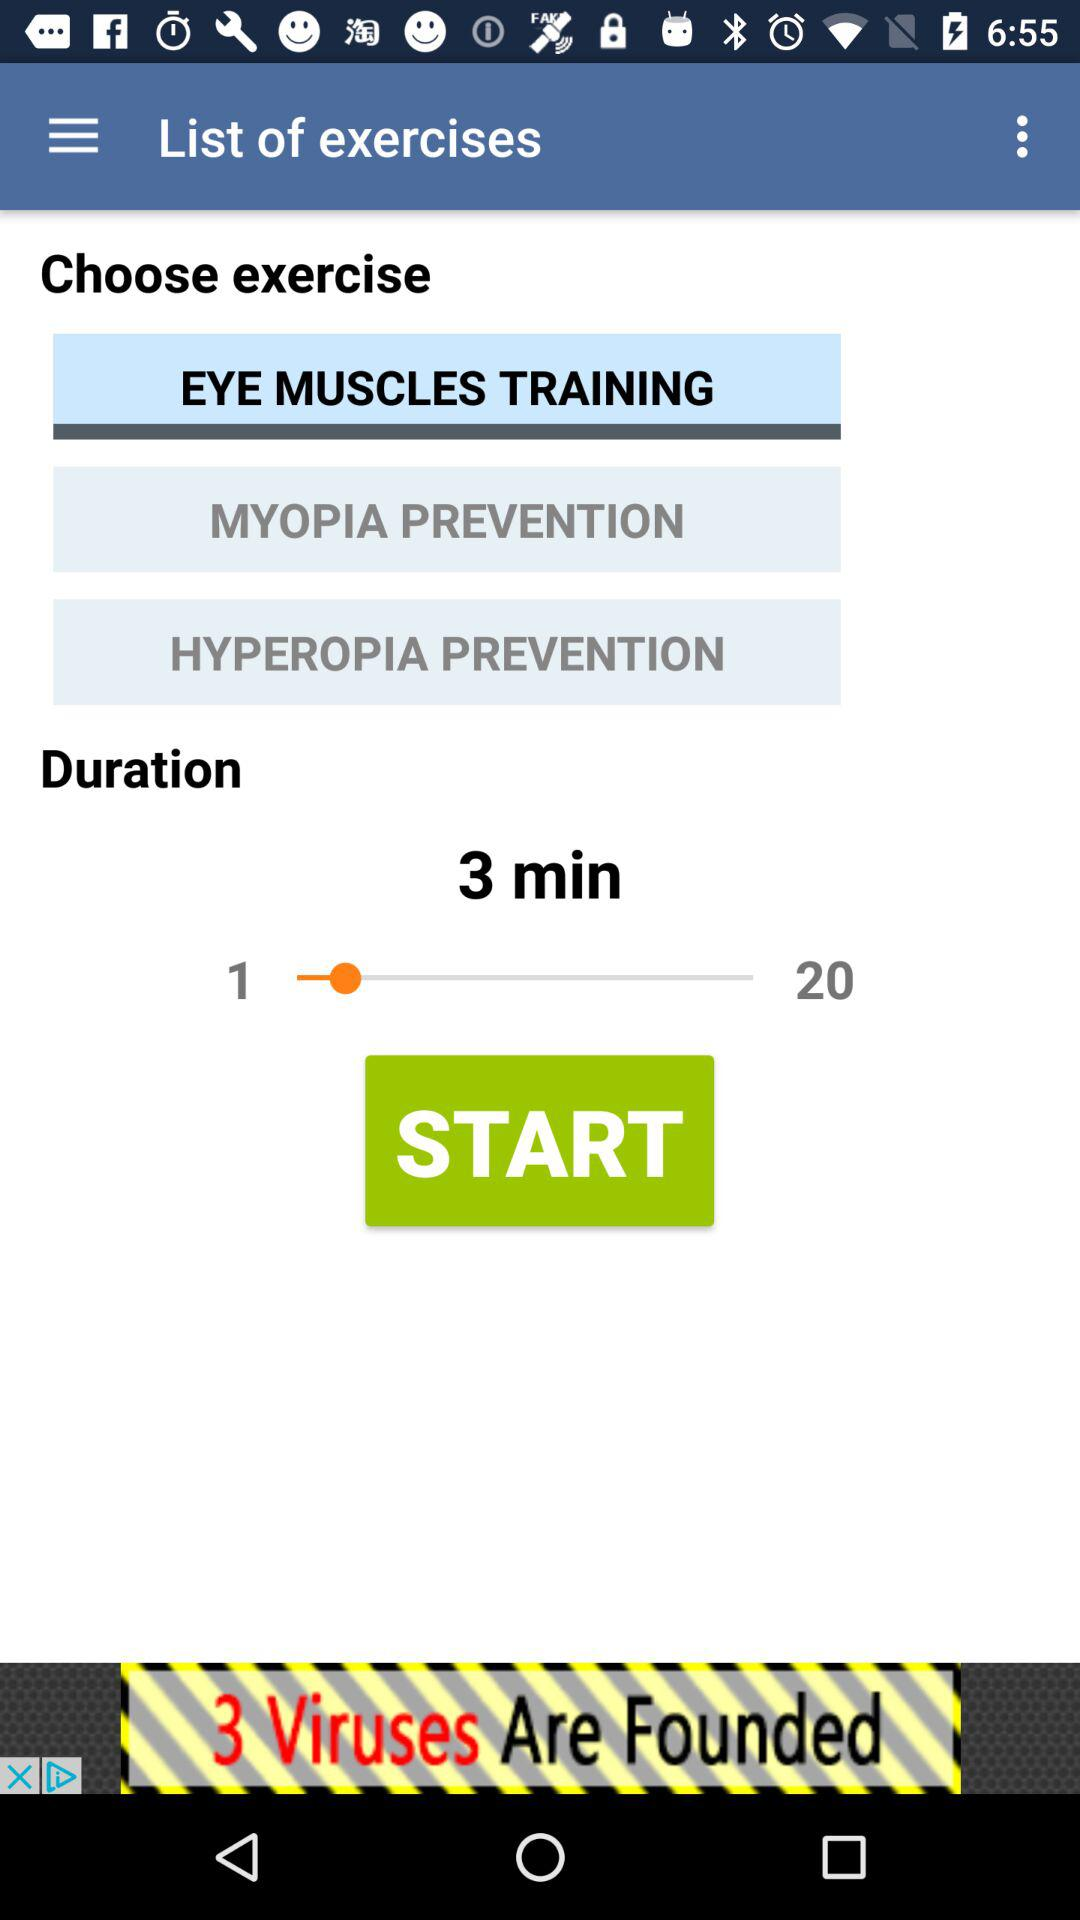What is the name of the selected exercise? The name of the selected exercise is "EYE MUSCLES TRAINING". 